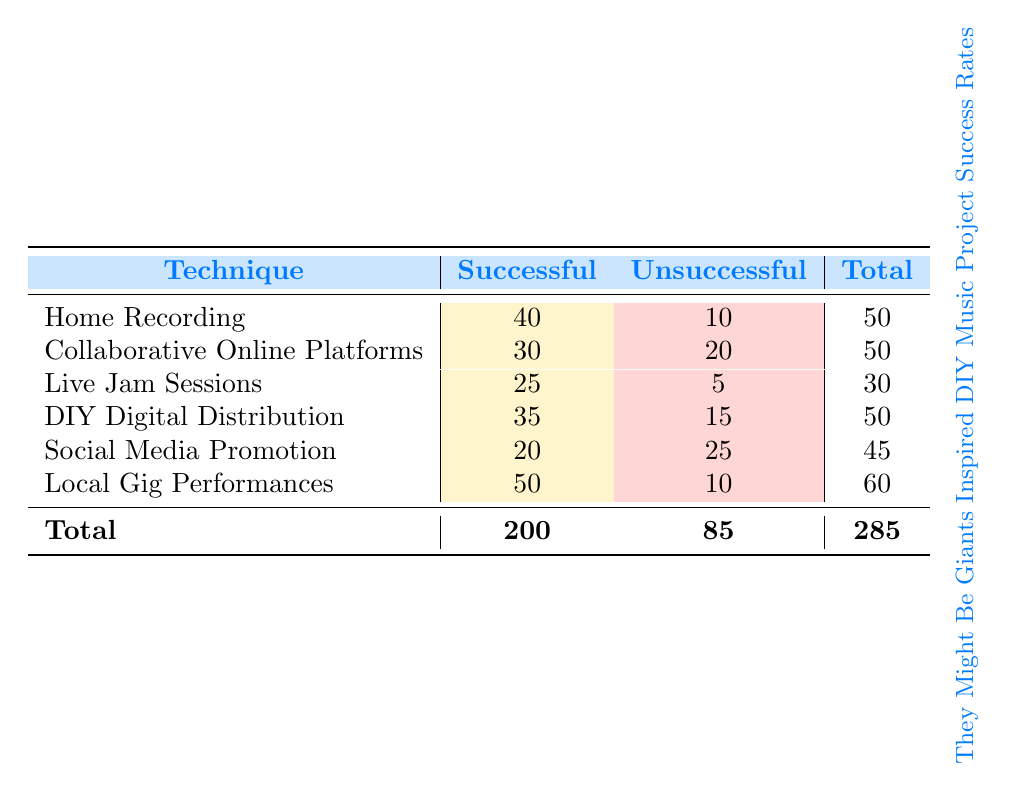What is the total number of successful DIY music projects? The total number of successful projects is given in the "Successful" column. Summing them up: 40 (Home Recording) + 30 (Collaborative Online Platforms) + 25 (Live Jam Sessions) + 35 (DIY Digital Distribution) + 20 (Social Media Promotion) + 50 (Local Gig Performances) = 200.
Answer: 200 Which technique had the highest number of unsuccessful projects? Looking at the "Unsuccessful" column, the highest number is 25 from "Social Media Promotion."
Answer: Social Media Promotion What is the total number of DIY music projects that used "Live Jam Sessions"? The total number of projects using "Live Jam Sessions" can be found in the "Total" column for that technique, which is 30.
Answer: 30 Did "Collaborative Online Platforms" have more successful projects than "DIY Digital Distribution"? Comparing the "Successful" counts: Collaborative Online Platforms has 30 and DIY Digital Distribution has 35. Since 30 is less than 35, the statement is false.
Answer: No What is the average number of successful projects across all techniques? To find the average, sum the successful projects (200) and divide by the number of techniques (6): 200 / 6 = 33.33.
Answer: 33.33 How many more successful than unsuccessful projects were there in "Local Gig Performances"? In "Local Gig Performances," there are 50 successful and 10 unsuccessful. The difference is 50 - 10 = 40.
Answer: 40 Which technique had the lowest success rate (successful projects / total projects)? Success rates are calculated as the number of successful projects divided by the total projects. Calculating each: Home Recording (40/50 = 0.80), Collaborative Online Platforms (30/50 = 0.60), Live Jam Sessions (25/30 = 0.83), DIY Digital Distribution (35/50 = 0.70), Social Media Promotion (20/45 = 0.44), Local Gig Performances (50/60 = 0.83). The lowest is Social Media Promotion at 0.44.
Answer: Social Media Promotion Is it true that more techniques had at least a 50% success rate than those that did not? The techniques with at least a 50% success rate are Home Recording, Live Jam Sessions, DIY Digital Distribution, and Local Gig Performances (4 techniques). Those under 50% are Collaborative Online Platforms and Social Media Promotion (2 techniques). Since 4 is greater than 2, the statement is true.
Answer: Yes What percentage of total DIY music projects were unsuccessful? The total number of unsuccessful projects is 85, and the total number of projects is 285. To find the percentage: (85 / 285) × 100 = 29.82%.
Answer: 29.82% 